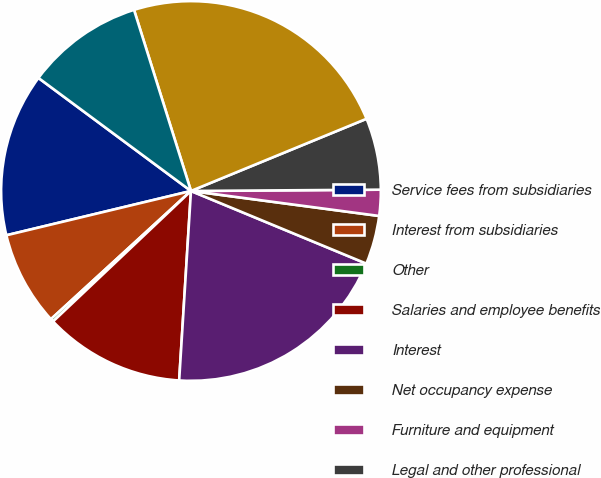<chart> <loc_0><loc_0><loc_500><loc_500><pie_chart><fcel>Service fees from subsidiaries<fcel>Interest from subsidiaries<fcel>Other<fcel>Salaries and employee benefits<fcel>Interest<fcel>Net occupancy expense<fcel>Furniture and equipment<fcel>Legal and other professional<fcel>Income (loss) before income<fcel>Income tax benefit<nl><fcel>13.9%<fcel>8.05%<fcel>0.26%<fcel>11.95%<fcel>19.74%<fcel>4.15%<fcel>2.21%<fcel>6.1%<fcel>23.64%<fcel>10.0%<nl></chart> 